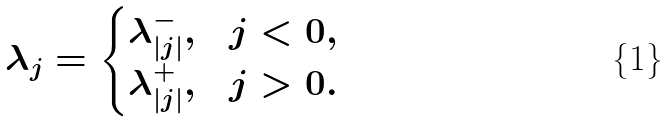Convert formula to latex. <formula><loc_0><loc_0><loc_500><loc_500>\lambda _ { j } = \begin{cases} \lambda ^ { - } _ { | j | } , & j < 0 , \\ \lambda ^ { + } _ { | j | } , & j > 0 . \end{cases}</formula> 